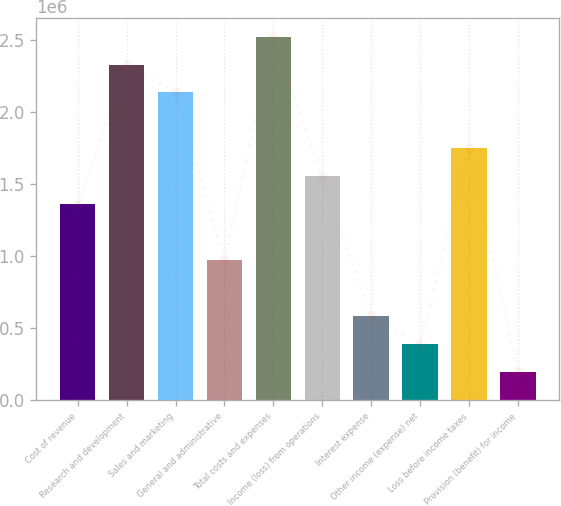Convert chart. <chart><loc_0><loc_0><loc_500><loc_500><bar_chart><fcel>Cost of revenue<fcel>Research and development<fcel>Sales and marketing<fcel>General and administrative<fcel>Total costs and expenses<fcel>Income (loss) from operations<fcel>Interest expense<fcel>Other income (expense) net<fcel>Loss before income taxes<fcel>Provision (benefit) for income<nl><fcel>1.35931e+06<fcel>2.33024e+06<fcel>2.13605e+06<fcel>970934<fcel>2.52443e+06<fcel>1.55349e+06<fcel>582561<fcel>388374<fcel>1.74768e+06<fcel>194188<nl></chart> 